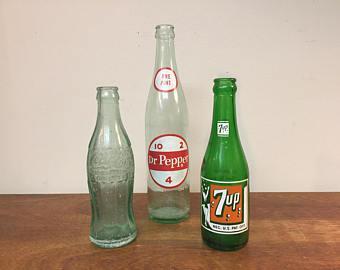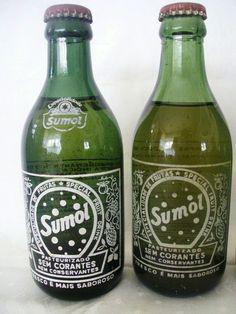The first image is the image on the left, the second image is the image on the right. Considering the images on both sides, is "Each image contains a single green glass soda bottle, and at least one bottle depicted has overlapping white circle shapes on its front." valid? Answer yes or no. No. The first image is the image on the left, the second image is the image on the right. Examine the images to the left and right. Is the description "Has atleast one picture of a drink that isn't Bubble Up" accurate? Answer yes or no. Yes. 